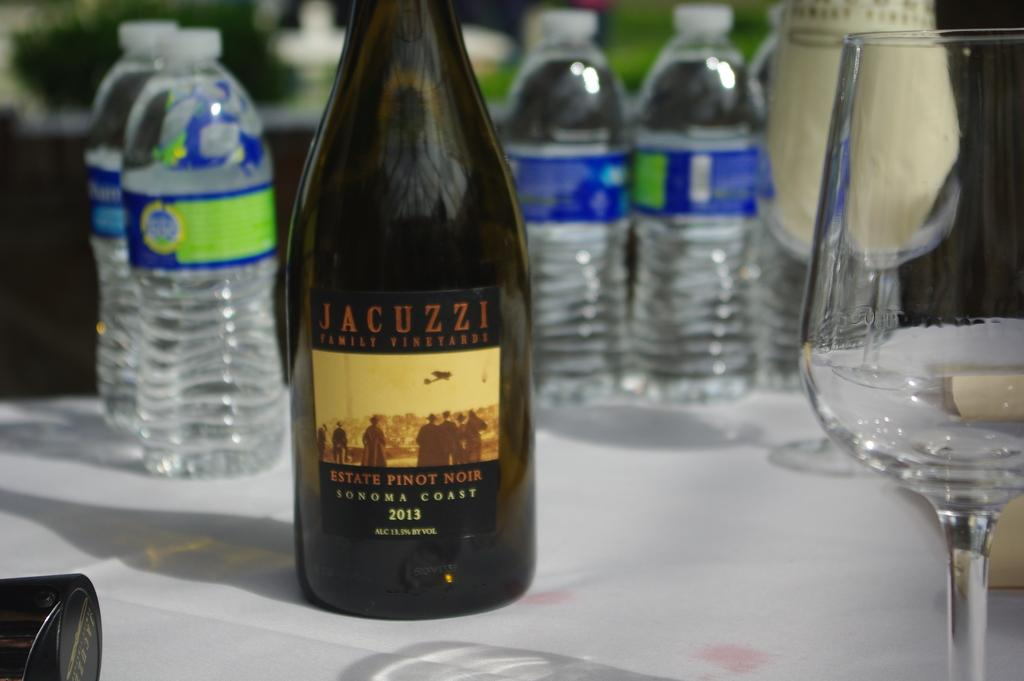<image>
Provide a brief description of the given image. A bottle of Jacuzzi Pinot Noir in front of water bottles. 